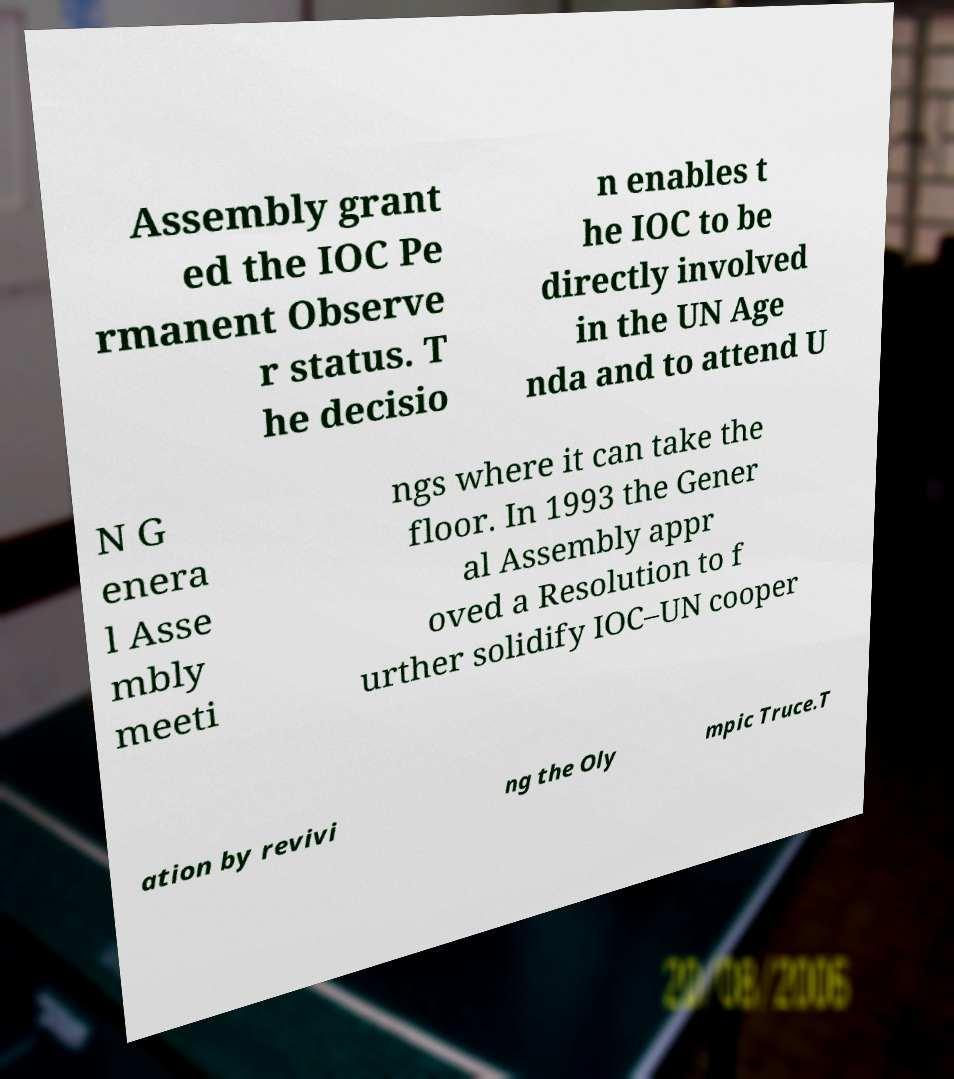Please read and relay the text visible in this image. What does it say? Assembly grant ed the IOC Pe rmanent Observe r status. T he decisio n enables t he IOC to be directly involved in the UN Age nda and to attend U N G enera l Asse mbly meeti ngs where it can take the floor. In 1993 the Gener al Assembly appr oved a Resolution to f urther solidify IOC–UN cooper ation by revivi ng the Oly mpic Truce.T 